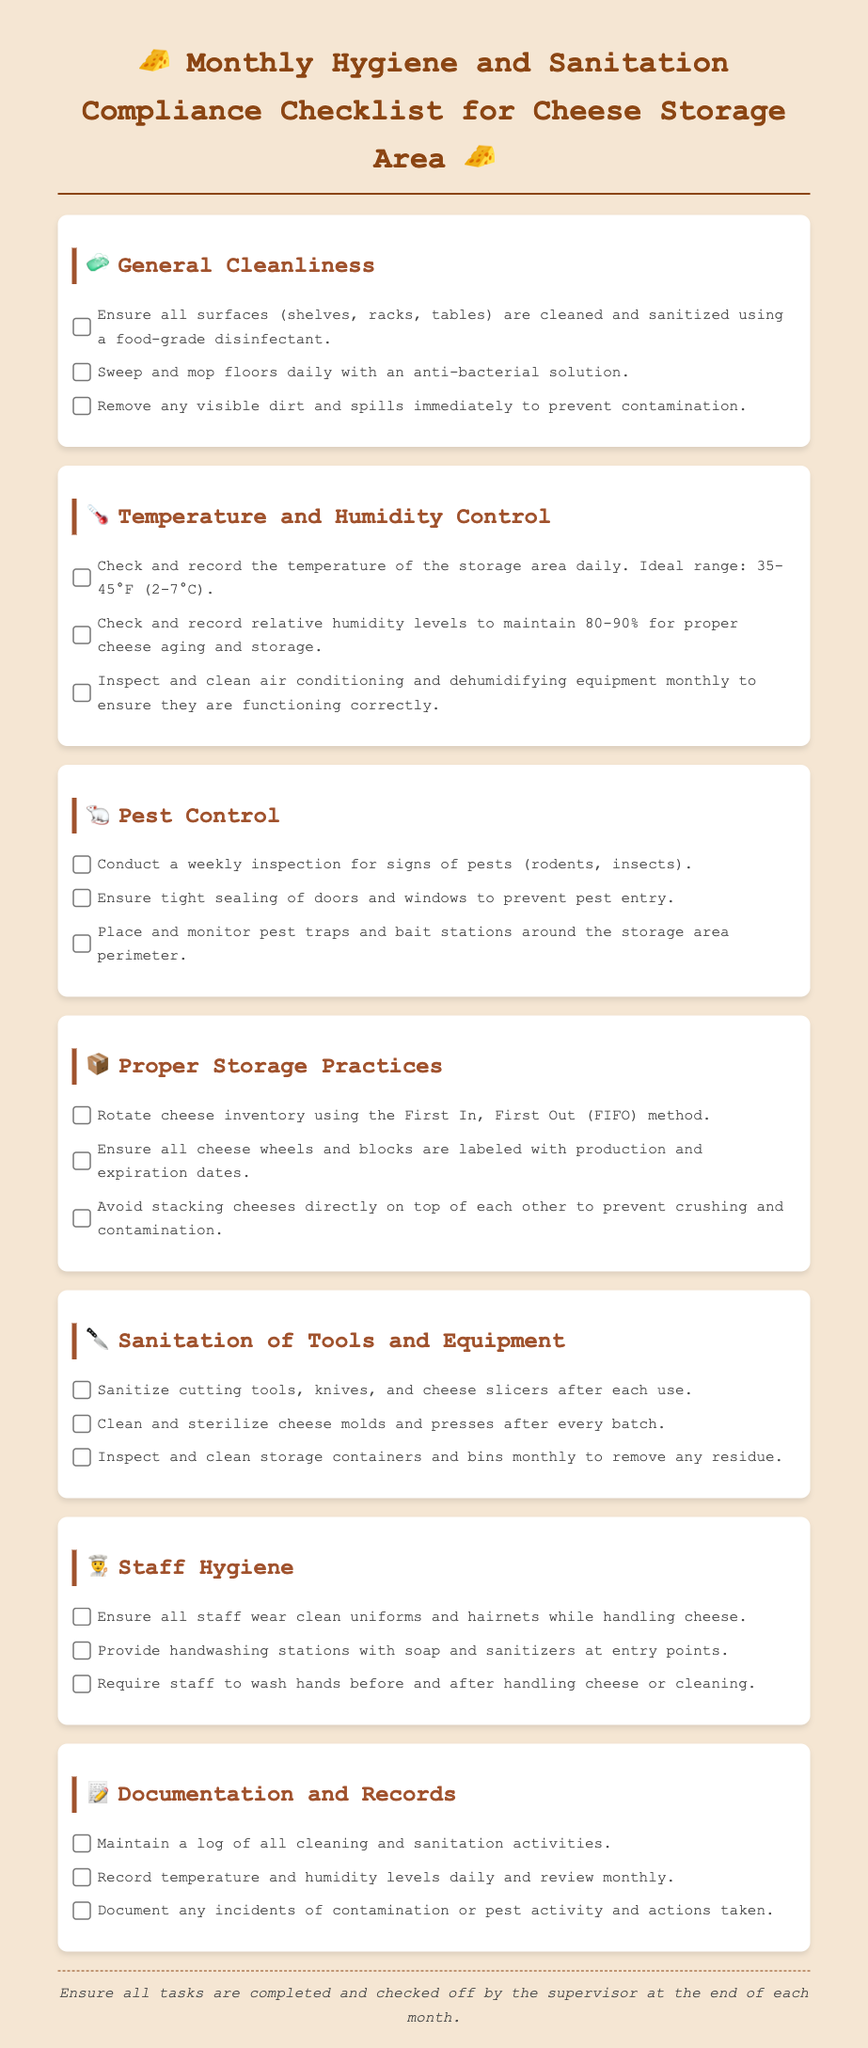What is the ideal temperature range for cheese storage? The ideal temperature range for cheese storage is specified in the document as 35-45°F (2-7°C).
Answer: 35-45°F (2-7°C) How often should pest inspections be conducted? The document states that pest inspections should be conducted weekly.
Answer: Weekly What percentage of humidity should be maintained for proper cheese aging? The document indicates that relative humidity levels should be maintained at 80-90%.
Answer: 80-90% What method should be used for rotating cheese inventory? The document advises using the First In, First Out (FIFO) method for cheese inventory rotation.
Answer: First In, First Out (FIFO) What is required from staff before handling cheese? The checklist requires staff to wash their hands before and after handling cheese or cleaning.
Answer: Wash hands What type of disinfectant should be used on surfaces? The document specifies the use of a food-grade disinfectant for cleaning surfaces.
Answer: Food-grade disinfectant How often should air conditioning and dehumidifying equipment be inspected? The document states that air conditioning and dehumidifying equipment should be inspected and cleaned monthly.
Answer: Monthly What should be documented regarding pest activity? The document states that any incidents of contamination or pest activity and actions taken should be documented.
Answer: Contamination incidents What should be done immediately if visible dirt or spills are found? The document states that visible dirt and spills should be removed immediately to prevent contamination.
Answer: Remove immediately 